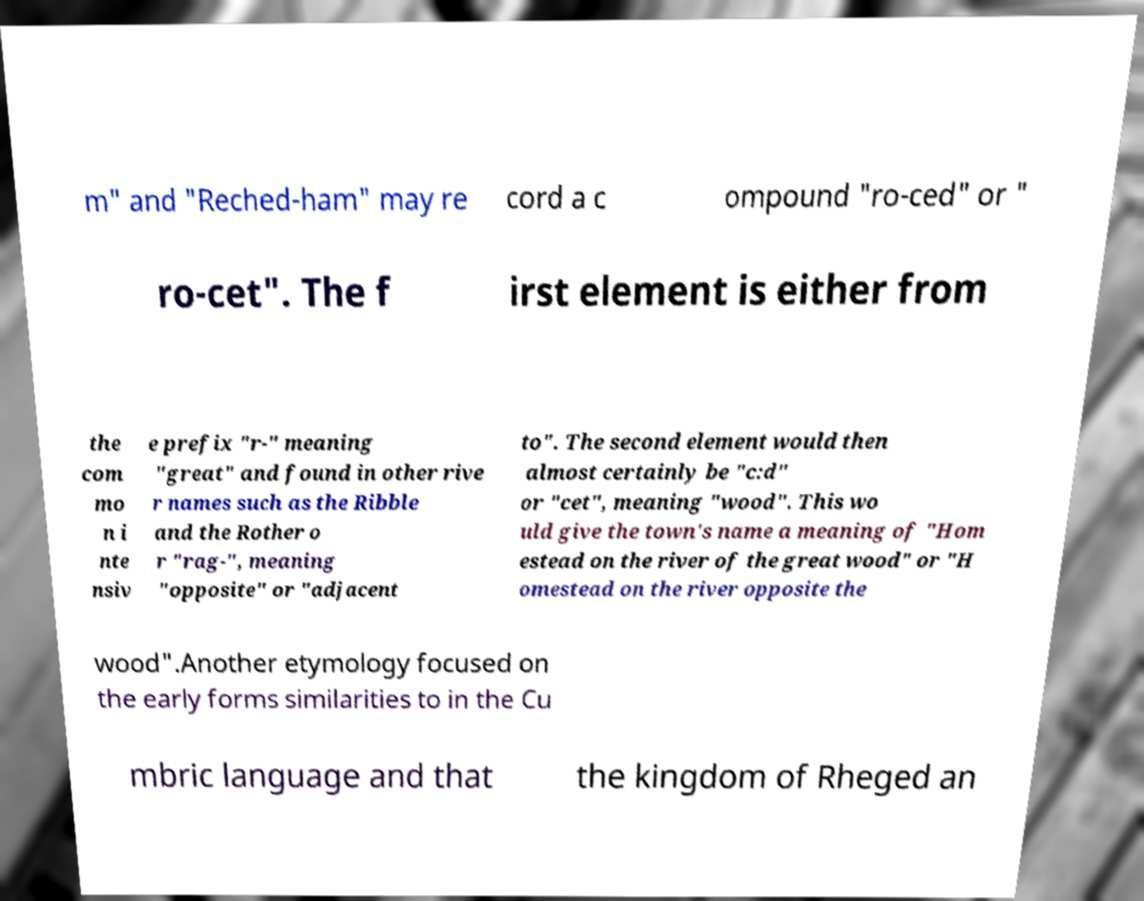Can you read and provide the text displayed in the image?This photo seems to have some interesting text. Can you extract and type it out for me? m" and "Reched-ham" may re cord a c ompound "ro-ced" or " ro-cet". The f irst element is either from the com mo n i nte nsiv e prefix "r-" meaning "great" and found in other rive r names such as the Ribble and the Rother o r "rag-", meaning "opposite" or "adjacent to". The second element would then almost certainly be "c:d" or "cet", meaning "wood". This wo uld give the town's name a meaning of "Hom estead on the river of the great wood" or "H omestead on the river opposite the wood".Another etymology focused on the early forms similarities to in the Cu mbric language and that the kingdom of Rheged an 